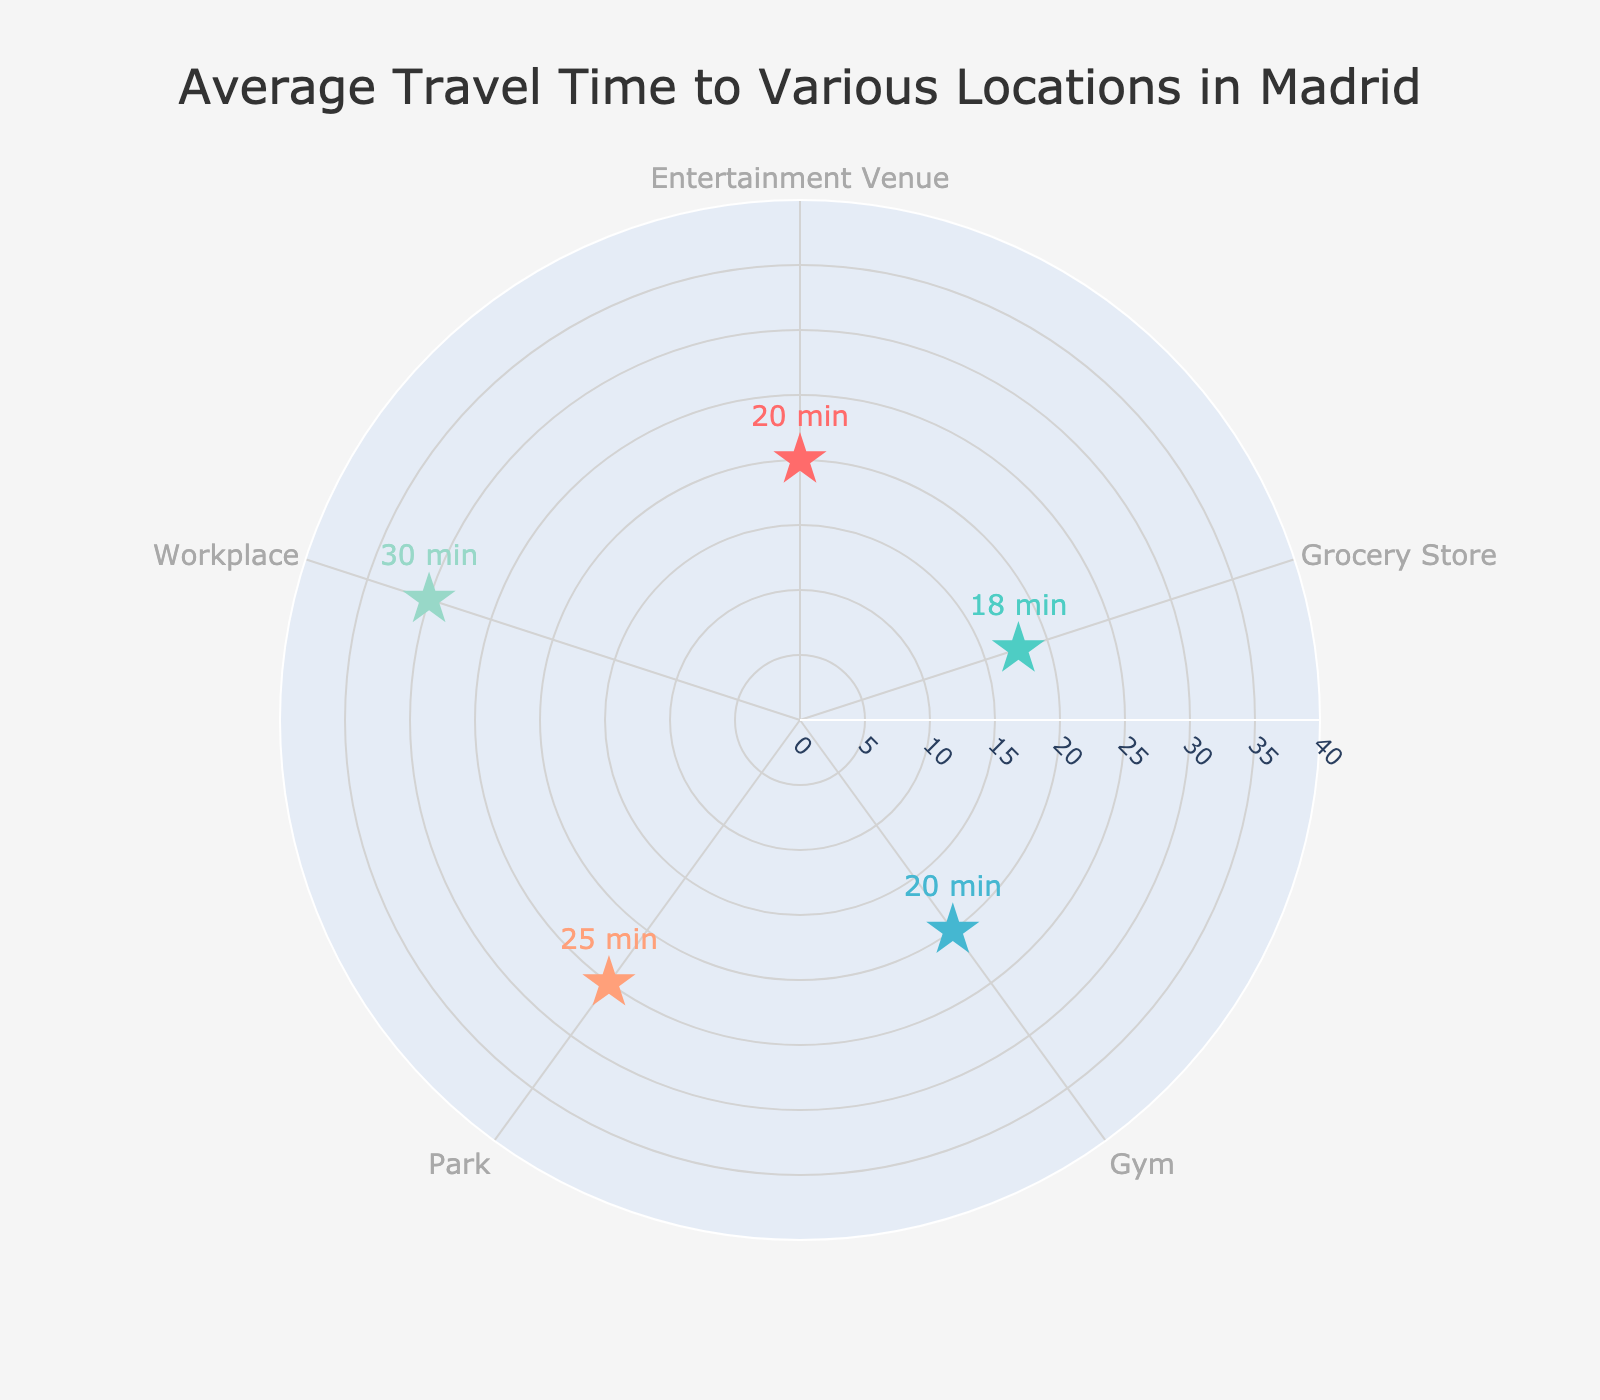What is the average travel time to a grocery store? By examining the figure, we can see the markers for the grocery stores category showing the text "18 min" which represents the average travel time to grocery stores
Answer: 18 min Which category has the longest average travel time, and what is it? Among all the categories plotted on the figure, 'Workplace' stands out as having the marker text "30 min," indicating it has the longest average travel time
Answer: Workplace, 30 min What is the difference in average travel time between parks and entertainment venues? The average travel time for parks is 25 minutes and for entertainment venues is 20 minutes. The difference is calculated as 25 - 20 = 5 minutes
Answer: 5 min How many categories have an average travel time of 25 minutes? Upon close inspection of the figure, we see that both the 'Park' and 'Workplace' categories have markers indicating an average travel time of 25 minutes
Answer: 2 Which category has the shortest average travel time, and what is it? By looking at all the marker texts, the category 'Grocery Store' has the shortest average travel time represented as "18 min"
Answer: Grocery Store, 18 min Between parks and gyms, which one has a higher average travel time, and by how much? Parks have an average travel time of 25 minutes while gyms have an average travel time of 20 minutes. The difference is calculated as 25 - 20 = 5 minutes
Answer: Parks, 5 min What is the combined average travel time for grocery stores, gyms, and entertainment venues? The average travel times are 18 minutes for grocery stores, 20 minutes for gyms, and 20 minutes for entertainment venues. Summing these up: 18 + 20 + 20 = 58 minutes
Answer: 58 min What can you infer about the distribution of average travel times among the different categories? From the plot, the average travel times for various categories appear to be relatively clustered between 15 and 30 minutes, with no extreme outliers indicating a relatively narrow range of travel times across different categories
Answer: Narrow distribution around 15-30 min 